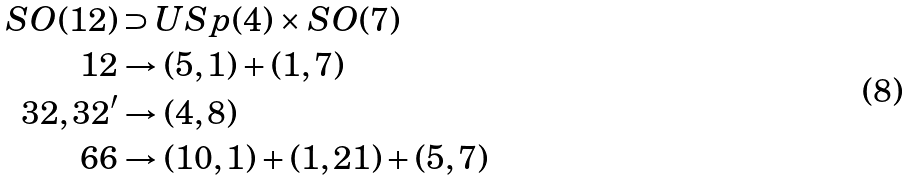Convert formula to latex. <formula><loc_0><loc_0><loc_500><loc_500>S O ( 1 2 ) & \supset U S p ( 4 ) \times S O ( 7 ) \\ 1 2 & \rightarrow ( 5 , 1 ) + ( 1 , 7 ) \\ 3 2 , 3 2 ^ { \prime } & \rightarrow ( 4 , 8 ) \\ 6 6 & \rightarrow ( 1 0 , 1 ) + ( 1 , 2 1 ) + ( 5 , 7 )</formula> 